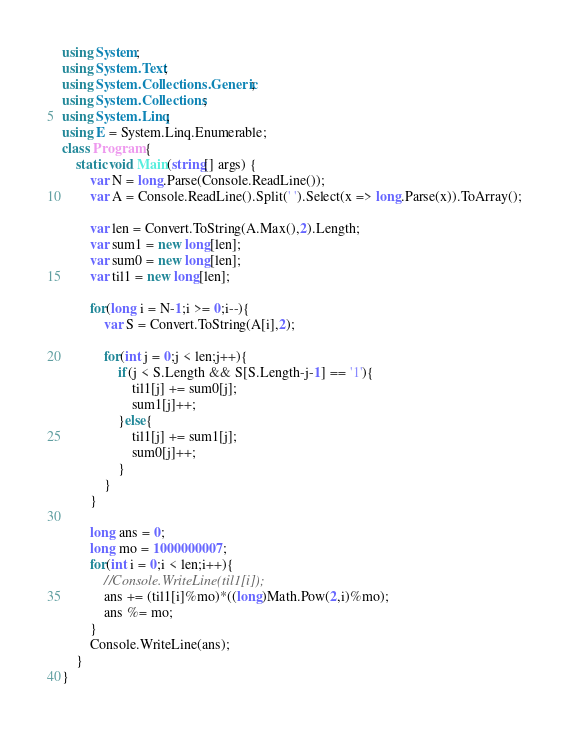<code> <loc_0><loc_0><loc_500><loc_500><_C#_>using System;
using System.Text;
using System.Collections.Generic;
using System.Collections;
using System.Linq;
using E = System.Linq.Enumerable;
class Program {
    static void Main(string[] args) {
        var N = long.Parse(Console.ReadLine());
        var A = Console.ReadLine().Split(' ').Select(x => long.Parse(x)).ToArray();
        
        var len = Convert.ToString(A.Max(),2).Length;
        var sum1 = new long[len];
        var sum0 = new long[len];
        var til1 = new long[len];
        
        for(long i = N-1;i >= 0;i--){
            var S = Convert.ToString(A[i],2);
            
            for(int j = 0;j < len;j++){
                if(j < S.Length && S[S.Length-j-1] == '1'){
                    til1[j] += sum0[j];
                    sum1[j]++;
                }else{
                    til1[j] += sum1[j];
                    sum0[j]++;
                }
            }
        }
        
        long ans = 0;
        long mo = 1000000007;
        for(int i = 0;i < len;i++){
            //Console.WriteLine(til1[i]);
            ans += (til1[i]%mo)*((long)Math.Pow(2,i)%mo);
            ans %= mo;
        }
        Console.WriteLine(ans);
    }
} 
</code> 